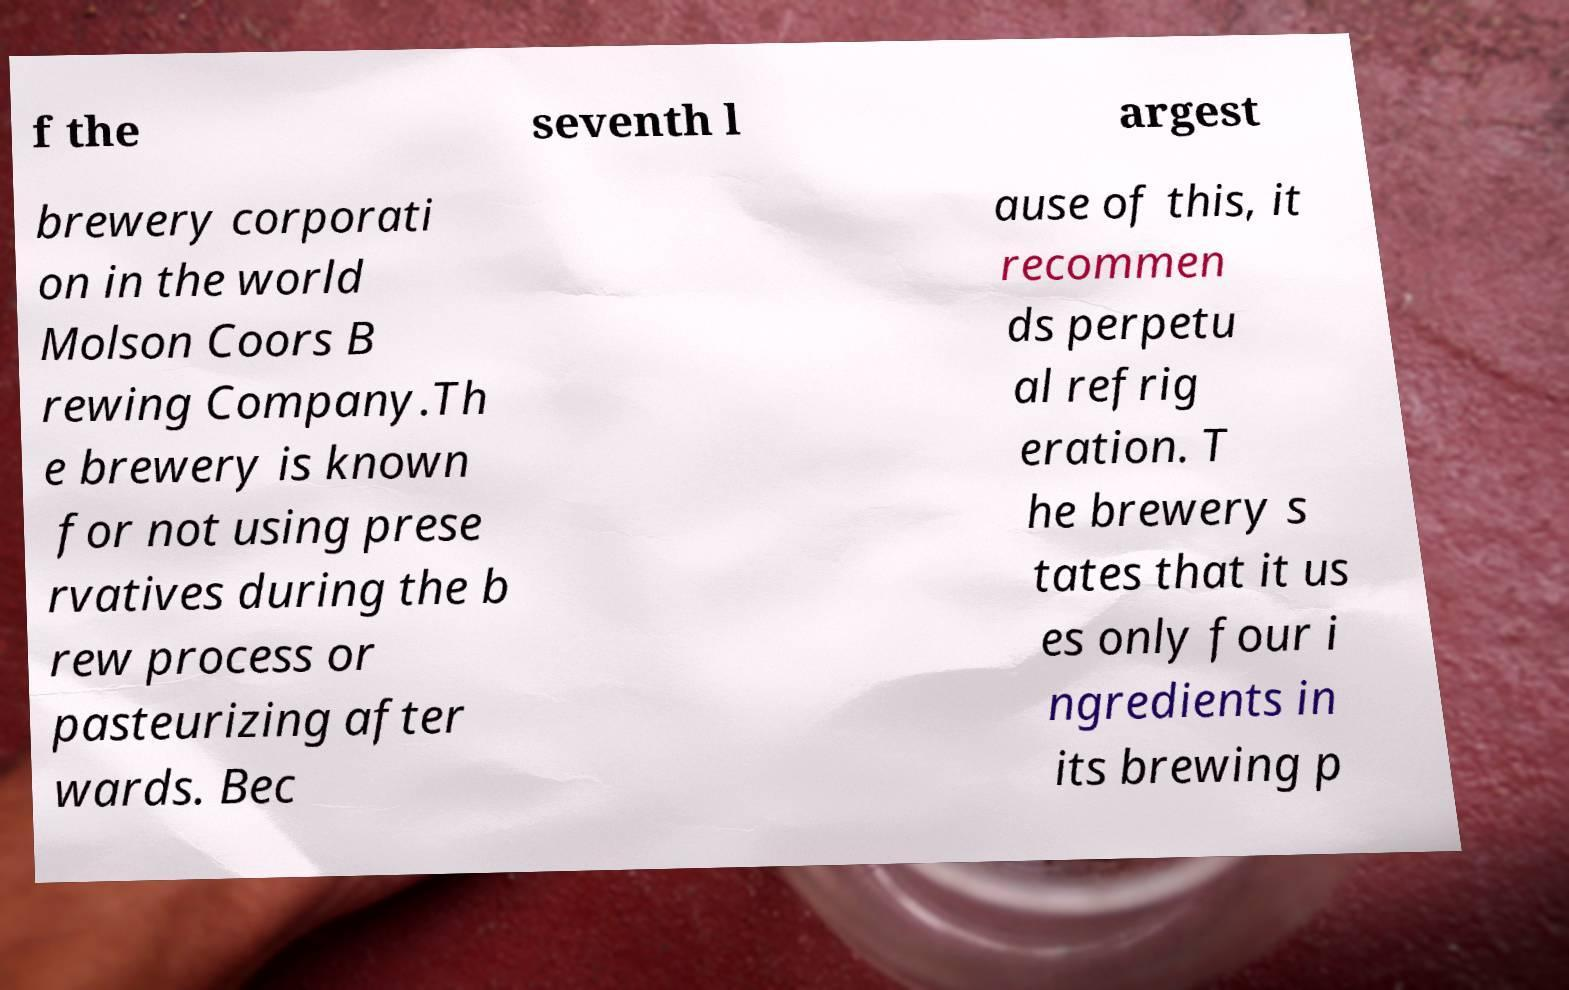Could you assist in decoding the text presented in this image and type it out clearly? f the seventh l argest brewery corporati on in the world Molson Coors B rewing Company.Th e brewery is known for not using prese rvatives during the b rew process or pasteurizing after wards. Bec ause of this, it recommen ds perpetu al refrig eration. T he brewery s tates that it us es only four i ngredients in its brewing p 